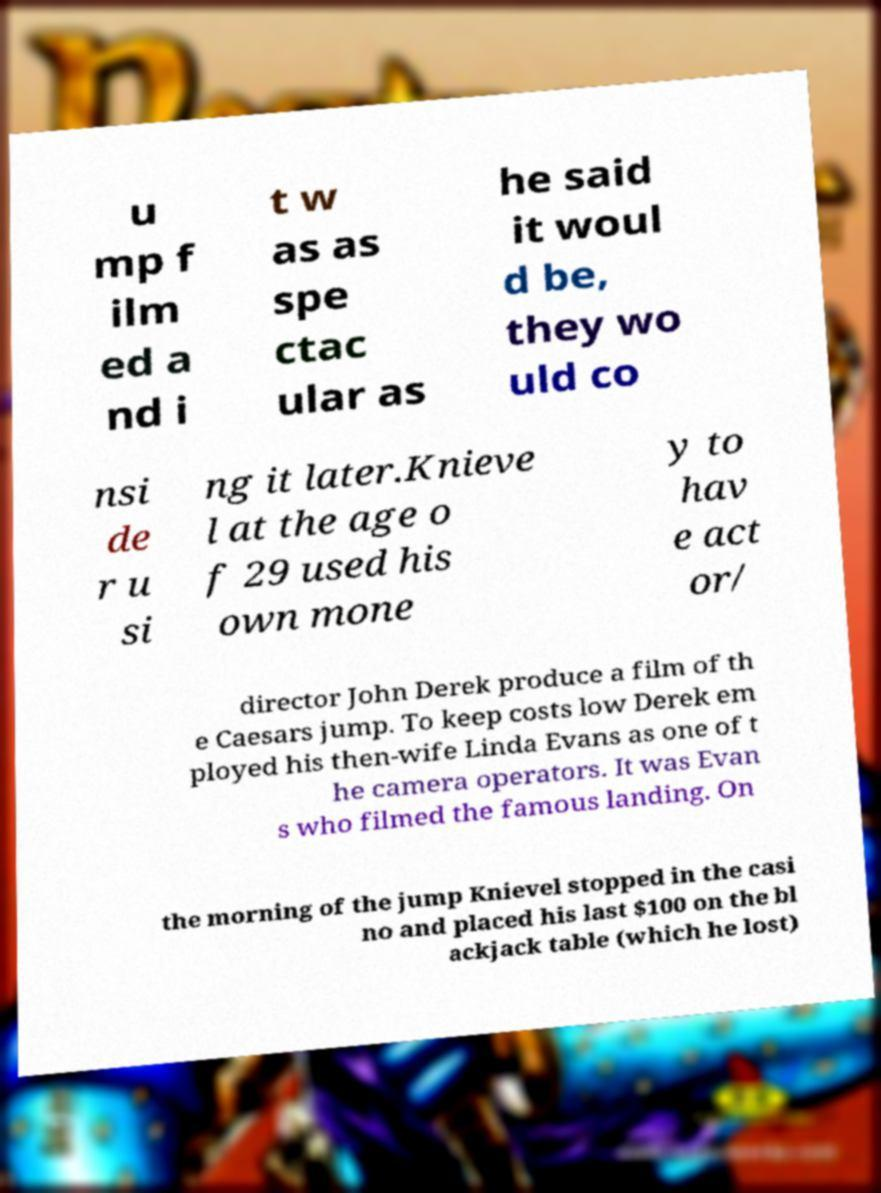Please read and relay the text visible in this image. What does it say? u mp f ilm ed a nd i t w as as spe ctac ular as he said it woul d be, they wo uld co nsi de r u si ng it later.Knieve l at the age o f 29 used his own mone y to hav e act or/ director John Derek produce a film of th e Caesars jump. To keep costs low Derek em ployed his then-wife Linda Evans as one of t he camera operators. It was Evan s who filmed the famous landing. On the morning of the jump Knievel stopped in the casi no and placed his last $100 on the bl ackjack table (which he lost) 